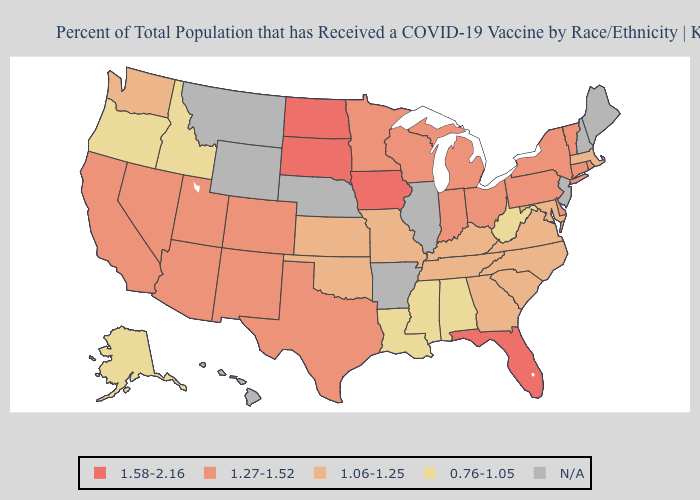Does the first symbol in the legend represent the smallest category?
Concise answer only. No. Among the states that border Oregon , does Nevada have the highest value?
Give a very brief answer. Yes. Among the states that border Mississippi , which have the lowest value?
Answer briefly. Alabama, Louisiana. Does Ohio have the highest value in the USA?
Be succinct. No. Among the states that border South Dakota , does Minnesota have the highest value?
Keep it brief. No. Which states have the lowest value in the West?
Keep it brief. Alaska, Idaho, Oregon. Among the states that border California , which have the highest value?
Write a very short answer. Arizona, Nevada. Does Connecticut have the lowest value in the Northeast?
Be succinct. No. What is the lowest value in the USA?
Be succinct. 0.76-1.05. Among the states that border Minnesota , which have the highest value?
Be succinct. Iowa, North Dakota, South Dakota. Among the states that border Florida , which have the lowest value?
Answer briefly. Alabama. 